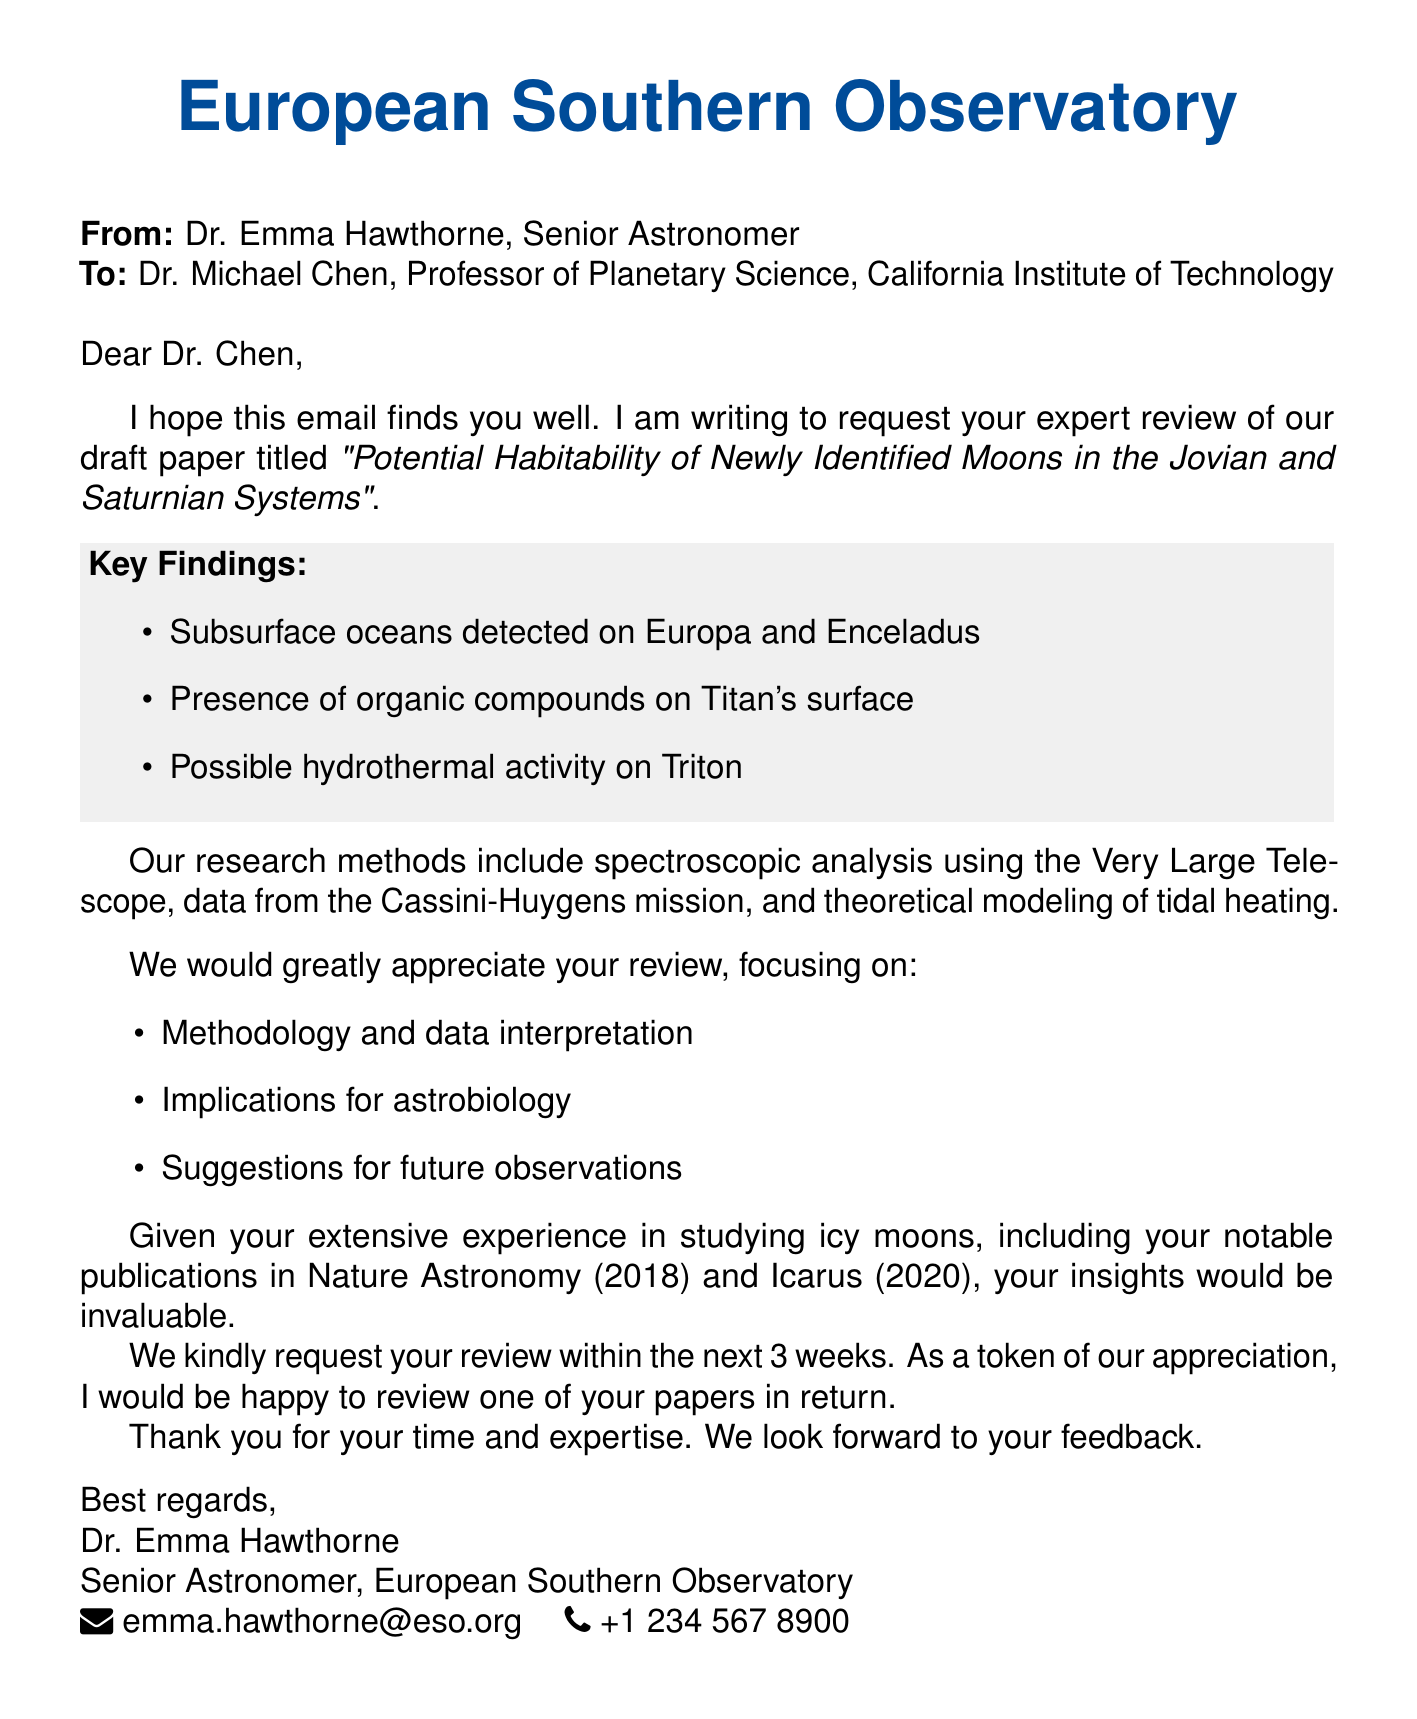what is the title of the paper? The title is explicitly stated in the document and is "Potential Habitability of Newly Identified Moons in the Jovian and Saturnian Systems."
Answer: Potential Habitability of Newly Identified Moons in the Jovian and Saturnian Systems who is the sender of the email? The sender's name and title are provided at the beginning of the email.
Answer: Dr. Emma Hawthorne what are the key findings listed in the document? Key findings are specified in a visually distinct section of the email.
Answer: Subsurface oceans detected on Europa and Enceladus; Presence of organic compounds on Titan's surface; Possible hydrothermal activity on Triton how long is the review deadline? The deadline is mentioned in the request details within the email.
Answer: Within 3 weeks what methods were used in the research? Methods are outlined in the document, detailing the techniques employed in the study.
Answer: Spectroscopic analysis using the Very Large Telescope; Data from the Cassini-Huygens mission; Theoretical modeling of tidal heating what areas should the review focus on? The email specifies the aspects that the reviewer should pay attention to during the review.
Answer: Methodology and data interpretation; Implications for astrobiology; Suggestions for future observations who are the co-authors of the paper? The document lists the authors of the paper, including the sender and others involved.
Answer: Sarah Rodriguez, James Keller what is offered in return for the review? The closing remarks include an offer made by the sender to the recipient.
Answer: Happy to review one of your papers in return 